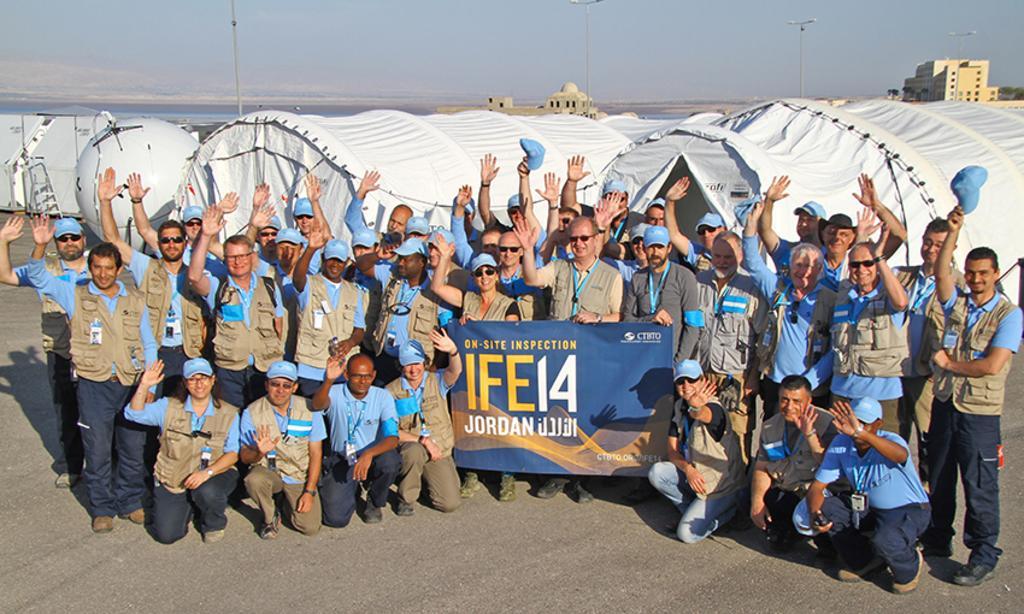How would you summarize this image in a sentence or two? In this image in the center there are a group of people who are standing and some of them are sitting on their knees, and two of them are holding one board. In the background there are some tents and some machines and buildings and some poles. On the top of the image there is sky at the bottom there is a road. 